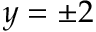Convert formula to latex. <formula><loc_0><loc_0><loc_500><loc_500>y = \pm 2</formula> 